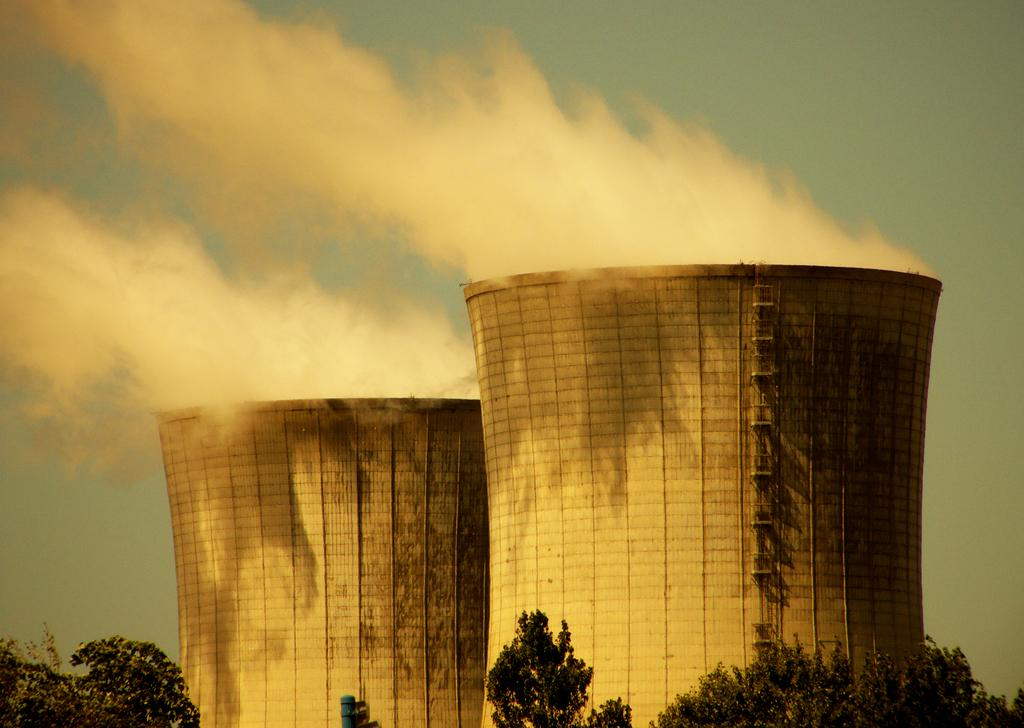What type of structures are visible in the image? There are two tall buildings in the image. What can be seen in the foreground of the image? There are trees in the foreground of the image. What is visible in the sky in the image? There are clouds in the sky in the image. How does the town breathe in the image? There is no town present in the image, and therefore the concept of breathing does not apply. 